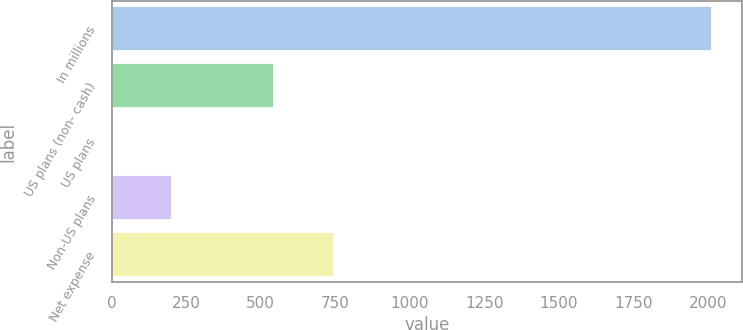Convert chart. <chart><loc_0><loc_0><loc_500><loc_500><bar_chart><fcel>In millions<fcel>US plans (non- cash)<fcel>US plans<fcel>Non-US plans<fcel>Net expense<nl><fcel>2013<fcel>545<fcel>1<fcel>202.2<fcel>746.2<nl></chart> 